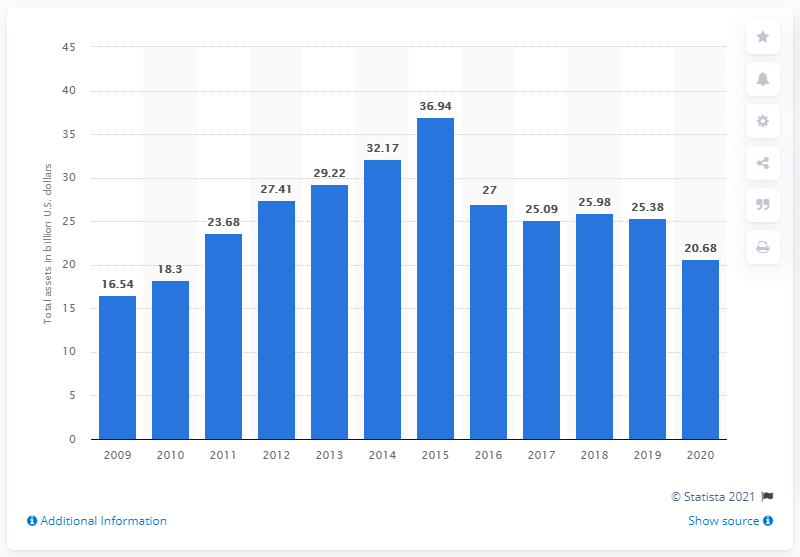Give some essential details in this illustration. The total assets of Halliburton are worth approximately 20.68. During the 2019-2020 fiscal year, the value of Halliburton's assets decreased by 20.68%. 